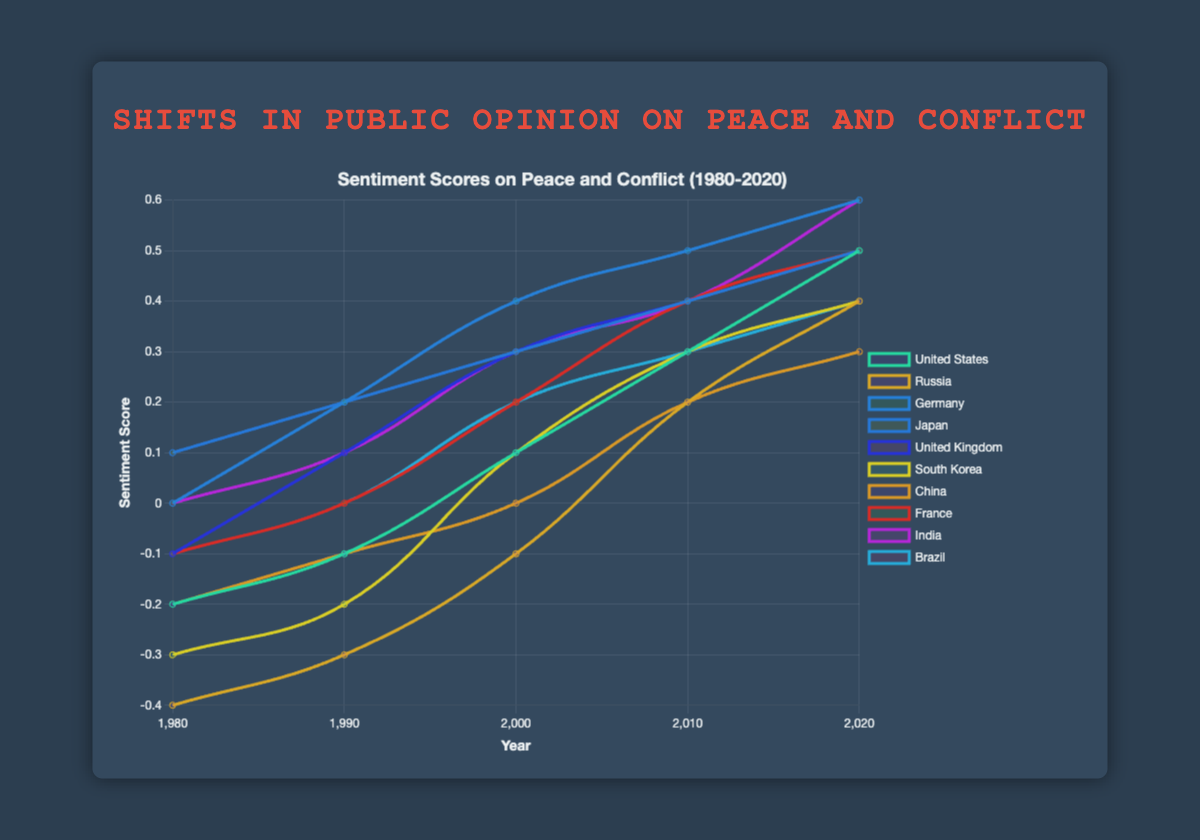What country shows the greatest increase in sentiment score from 1980 to 2020? First, identify the sentiment scores for all countries in 1980 and 2020. Then, calculate the difference for each country and determine which country has the greatest increase. For example, the increase for the United States is (0.5 - (-0.2)) = 0.7, and similarly for other countries. The comparison shows that Germany, Japan, India, and the United Kingdom all have similar high increases, but India has the highest with an increase of 0.6.
Answer: India Which country has the least positive sentiment score in 2020? Refer to the sentiment scores in 2020 and locate the minimum value. The sentiment scores in 2020 are: United States (0.5), Russia (0.4), Germany (0.6), Japan (0.5), United Kingdom (0.5), South Korea (0.4), China (0.3), France (0.5), India (0.6), Brazil (0.4). The least positive sentiment score is 0.3 by China.
Answer: China What is the average sentiment score for Brazil over the decades shown? List out Brazil's sentiment scores: -0.1 (1980), 0.0 (1990), 0.2 (2000), 0.3 (2010), 0.4 (2020). Calculate the average: ((-0.1) + 0.0 + 0.2 + 0.3 + 0.4) / 5 = 0.16.
Answer: 0.16 Compare the sentiment scores of Russia and South Korea in 1990. Which country had a higher score? Check the sentiment scores for Russia and South Korea in 1990. Russia's score is -0.3 and South Korea's score is -0.2. Clearly, South Korea had a higher score.
Answer: South Korea In what year does Germany first surpass a sentiment score of 0.3? Analyze the sentiment scores for Germany by each year: 1980 (0.0), 1990 (0.2), 2000 (0.4), 2010 (0.5), 2020 (0.6). The first score surpassing 0.3 is in the year 2000.
Answer: 2000 Which countries have a sentiment score of 0.4 in 2010? Refer to the sentiment scores in 2010 and identify which countries have a score of 0.4. The countries are Russia, Japan, United Kingdom, France, and Brazil.
Answer: Russia, Japan, United Kingdom, France, Brazil Calculate the range of sentiment scores for the United States across all years. List the sentiment scores for the United States: -0.2, -0.1, 0.1, 0.3, 0.5. The range is calculated as the difference between the maximum and minimum values: 0.5 - (-0.2) = 0.7.
Answer: 0.7 How many countries had a negative sentiment score in 1980? Count the number of countries with sentiment scores less than 0 in 1980. The countries are: United States (-0.2), Russia (-0.4), United Kingdom (-0.1), South Korea (-0.3), China (-0.2), France (-0.1), Brazil (-0.1). There are 7 countries in total.
Answer: 7 Which country shows the most consistent increase in sentiment score from 1980 to 2020? Observe the trend lines for each country and how consistently their sentiment scores increase every decade. Japan, which progresses smoothly from 0.1 to 0.2, then to 0.3, 0.4, and finally 0.5, shows the most consistent increase without fluctuations.
Answer: Japan 